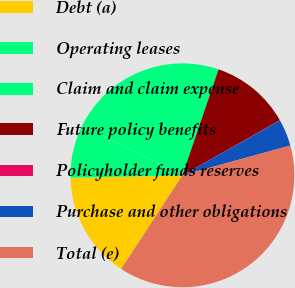Convert chart. <chart><loc_0><loc_0><loc_500><loc_500><pie_chart><fcel>Debt (a)<fcel>Operating leases<fcel>Claim and claim expense<fcel>Future policy benefits<fcel>Policyholder funds reserves<fcel>Purchase and other obligations<fcel>Total (e)<nl><fcel>15.42%<fcel>7.72%<fcel>22.88%<fcel>11.57%<fcel>0.03%<fcel>3.88%<fcel>38.51%<nl></chart> 